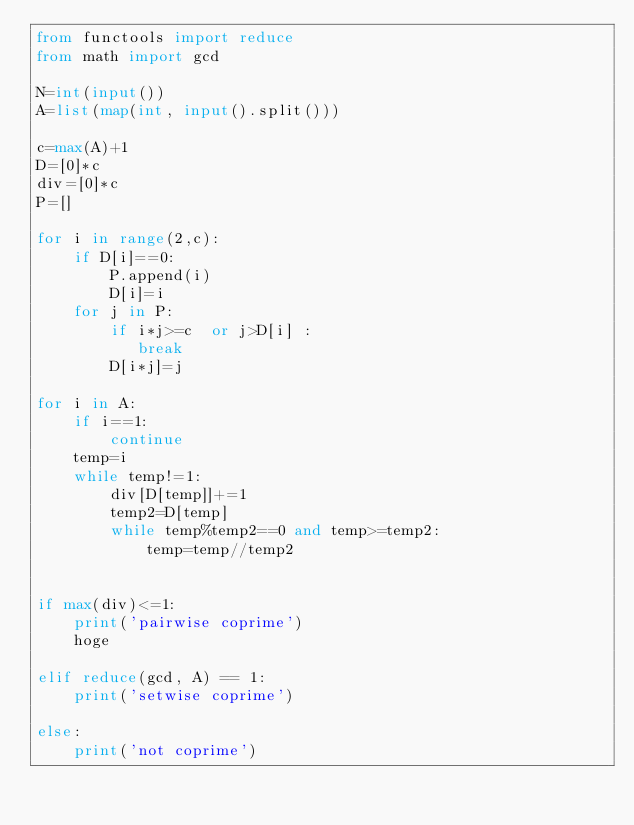Convert code to text. <code><loc_0><loc_0><loc_500><loc_500><_Python_>from functools import reduce
from math import gcd

N=int(input())
A=list(map(int, input().split()))

c=max(A)+1
D=[0]*c
div=[0]*c
P=[]

for i in range(2,c):
    if D[i]==0:
        P.append(i)
        D[i]=i
    for j in P:
        if i*j>=c  or j>D[i] :
           break
        D[i*j]=j

for i in A:
    if i==1:
        continue
    temp=i
    while temp!=1:
        div[D[temp]]+=1
        temp2=D[temp]
        while temp%temp2==0 and temp>=temp2:
            temp=temp//temp2


if max(div)<=1:
    print('pairwise coprime')
    hoge

elif reduce(gcd, A) == 1:
    print('setwise coprime')

else:
    print('not coprime')</code> 